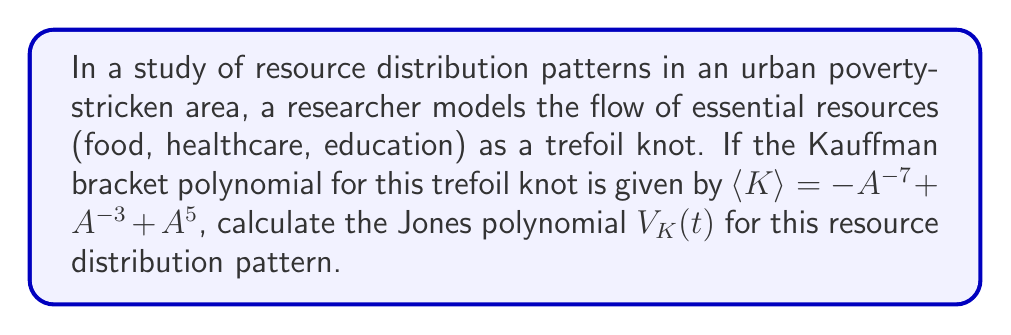What is the answer to this math problem? To calculate the Jones polynomial from the Kauffman bracket polynomial, we follow these steps:

1) Recall that the Jones polynomial $V_K(t)$ is related to the Kauffman bracket polynomial $\langle K \rangle$ by the formula:

   $V_K(t) = (-A^{-3})^{-w(K)} \cdot \langle K \rangle |_{A = t^{-1/4}}$

   where $w(K)$ is the writhe of the knot.

2) For a standard diagram of the right-handed trefoil knot, the writhe $w(K) = 3$.

3) Substitute the given Kauffman bracket polynomial:

   $V_K(t) = (-A^{-3})^{-3} \cdot (-A^{-7} + A^{-3} + A^{5})|_{A = t^{-1/4}}$

4) Simplify the first part:

   $V_K(t) = -A^9 \cdot (-A^{-7} + A^{-3} + A^{5})|_{A = t^{-1/4}}$

5) Distribute:

   $V_K(t) = (A^2 - A^6 - A^{14})|_{A = t^{-1/4}}$

6) Now substitute $A = t^{-1/4}$:

   $V_K(t) = (t^{-1/2} - t^{-3/2} - t^{-7/2})$

7) To express this in the standard form of the Jones polynomial, multiply by $t^{7/2}$:

   $V_K(t) = t^3 - t^2 - 1$

This is the Jones polynomial for the trefoil knot, which in this context represents the resource distribution pattern in the urban poverty-stricken area.
Answer: $V_K(t) = t^3 - t^2 - 1$ 